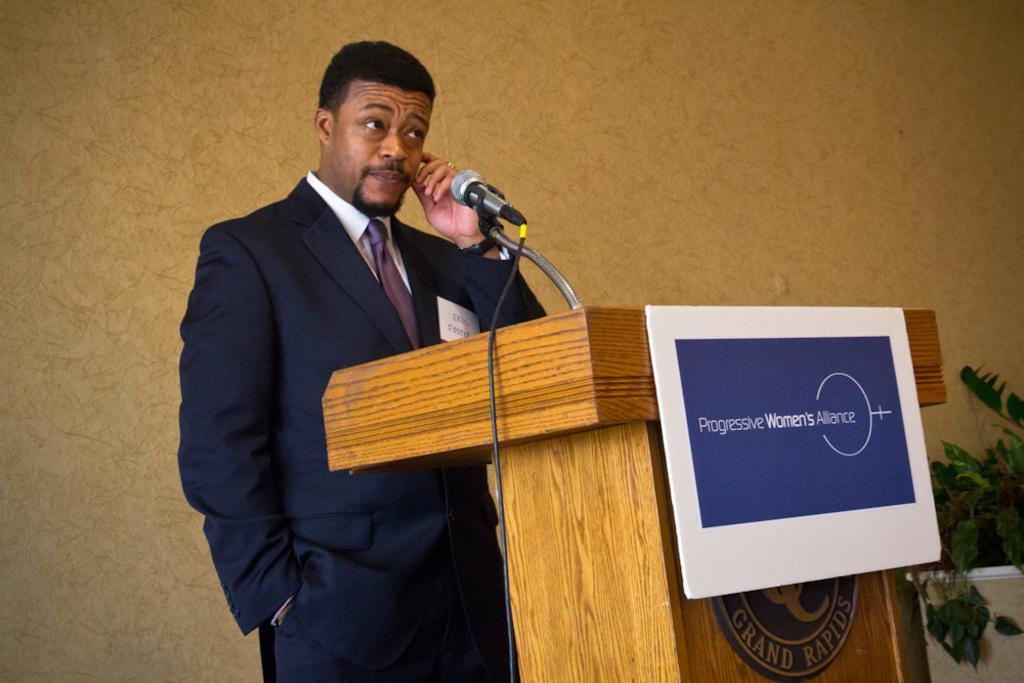Can you describe this image briefly? In the center of the image we can see a man standing, before him there is a podium and we can see a mic placed on the stand. On the right there is a houseplant. In the background there is a wall. 